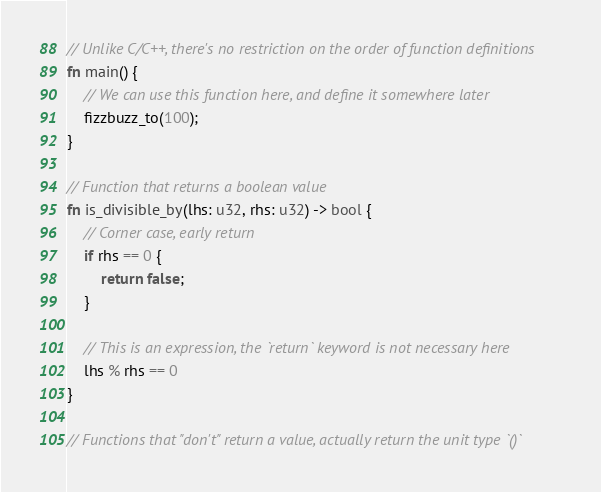<code> <loc_0><loc_0><loc_500><loc_500><_Rust_>// Unlike C/C++, there's no restriction on the order of function definitions
fn main() {
    // We can use this function here, and define it somewhere later
    fizzbuzz_to(100);
}

// Function that returns a boolean value
fn is_divisible_by(lhs: u32, rhs: u32) -> bool {
    // Corner case, early return
    if rhs == 0 {
        return false;
    }

    // This is an expression, the `return` keyword is not necessary here
    lhs % rhs == 0
}

// Functions that "don't" return a value, actually return the unit type `()`</code> 